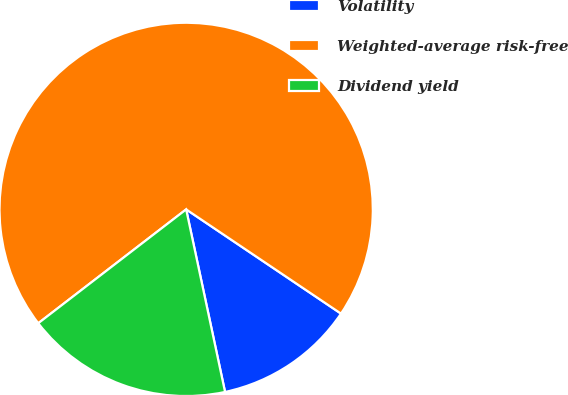Convert chart. <chart><loc_0><loc_0><loc_500><loc_500><pie_chart><fcel>Volatility<fcel>Weighted-average risk-free<fcel>Dividend yield<nl><fcel>12.23%<fcel>69.87%<fcel>17.9%<nl></chart> 